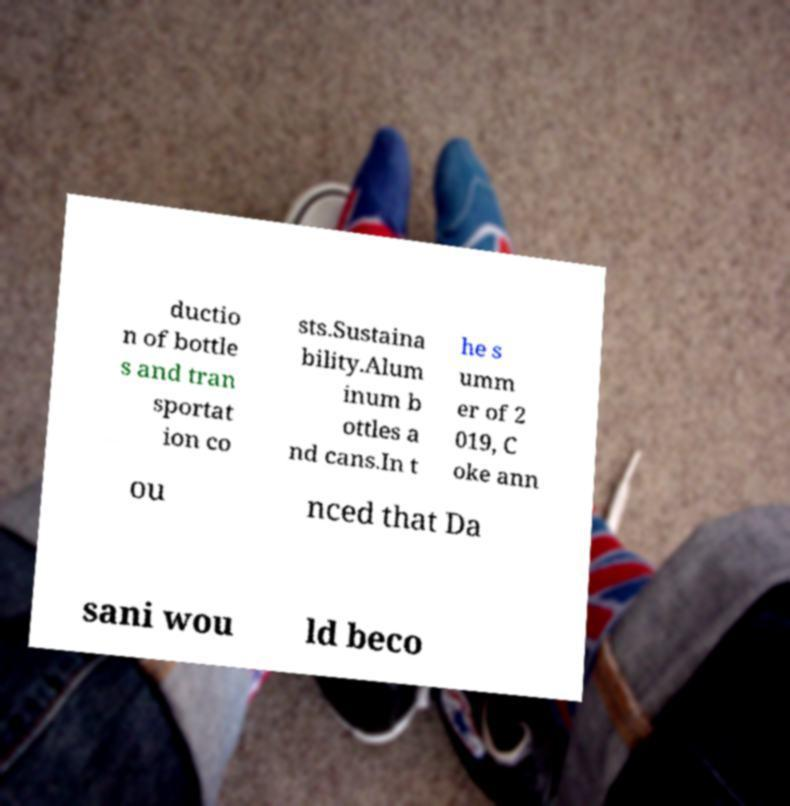There's text embedded in this image that I need extracted. Can you transcribe it verbatim? ductio n of bottle s and tran sportat ion co sts.Sustaina bility.Alum inum b ottles a nd cans.In t he s umm er of 2 019, C oke ann ou nced that Da sani wou ld beco 